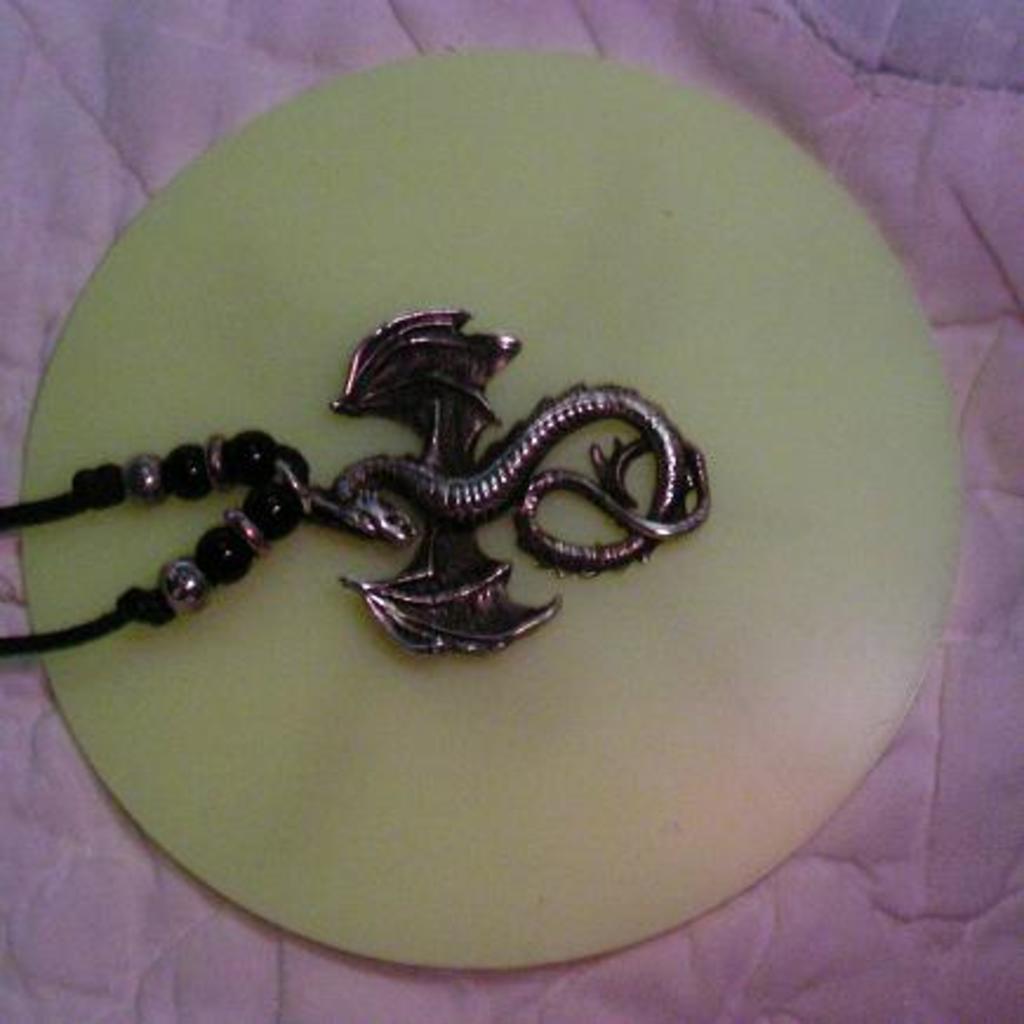Could you give a brief overview of what you see in this image? The picture consists of a chain on a round glass like object. On the edges we can see a pink colored cloth. 